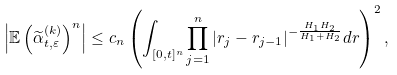Convert formula to latex. <formula><loc_0><loc_0><loc_500><loc_500>\left | \mathbb { E } \left ( \widetilde { \alpha } _ { t , \varepsilon } ^ { ( k ) } \right ) ^ { n } \right | & \leq c _ { n } \left ( \int _ { [ 0 , t ] ^ { n } } \prod _ { j = 1 } ^ { n } | r _ { j } - r _ { j - 1 } | ^ { - \frac { H _ { 1 } H _ { 2 } } { H _ { 1 } + H _ { 2 } } } d r \right ) ^ { 2 } ,</formula> 